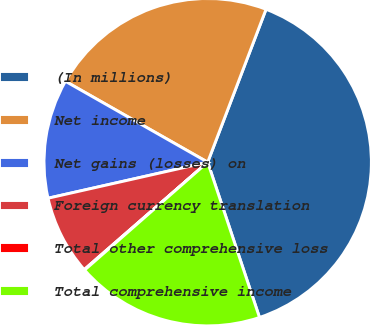<chart> <loc_0><loc_0><loc_500><loc_500><pie_chart><fcel>(In millions)<fcel>Net income<fcel>Net gains (losses) on<fcel>Foreign currency translation<fcel>Total other comprehensive loss<fcel>Total comprehensive income<nl><fcel>39.07%<fcel>22.57%<fcel>11.76%<fcel>7.86%<fcel>0.06%<fcel>18.67%<nl></chart> 